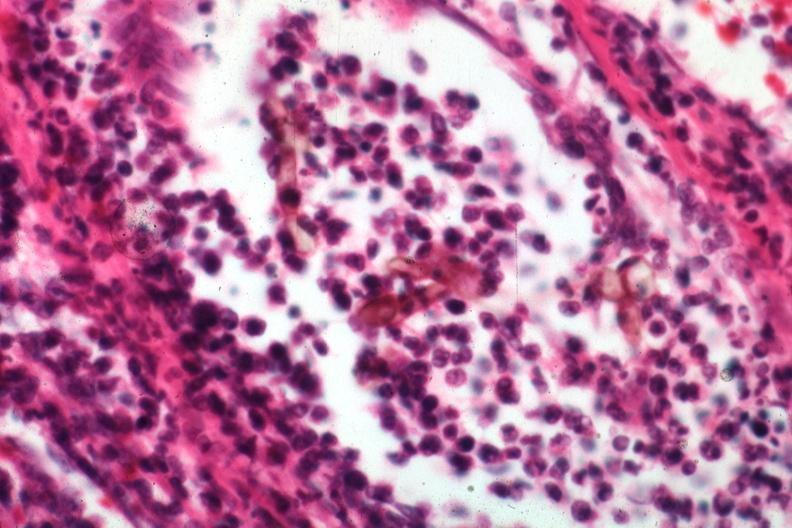what is present?
Answer the question using a single word or phrase. Chromoblastomycosis 